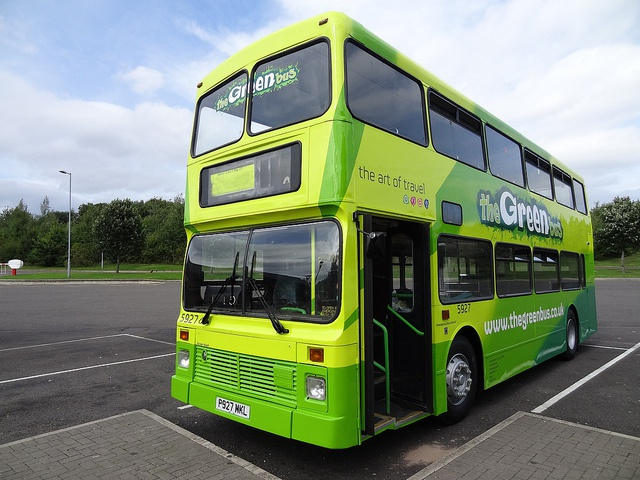Describe the objects in this image and their specific colors. I can see bus in lightblue, black, gray, green, and khaki tones in this image. 